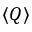Convert formula to latex. <formula><loc_0><loc_0><loc_500><loc_500>\left \langle Q \right \rangle</formula> 